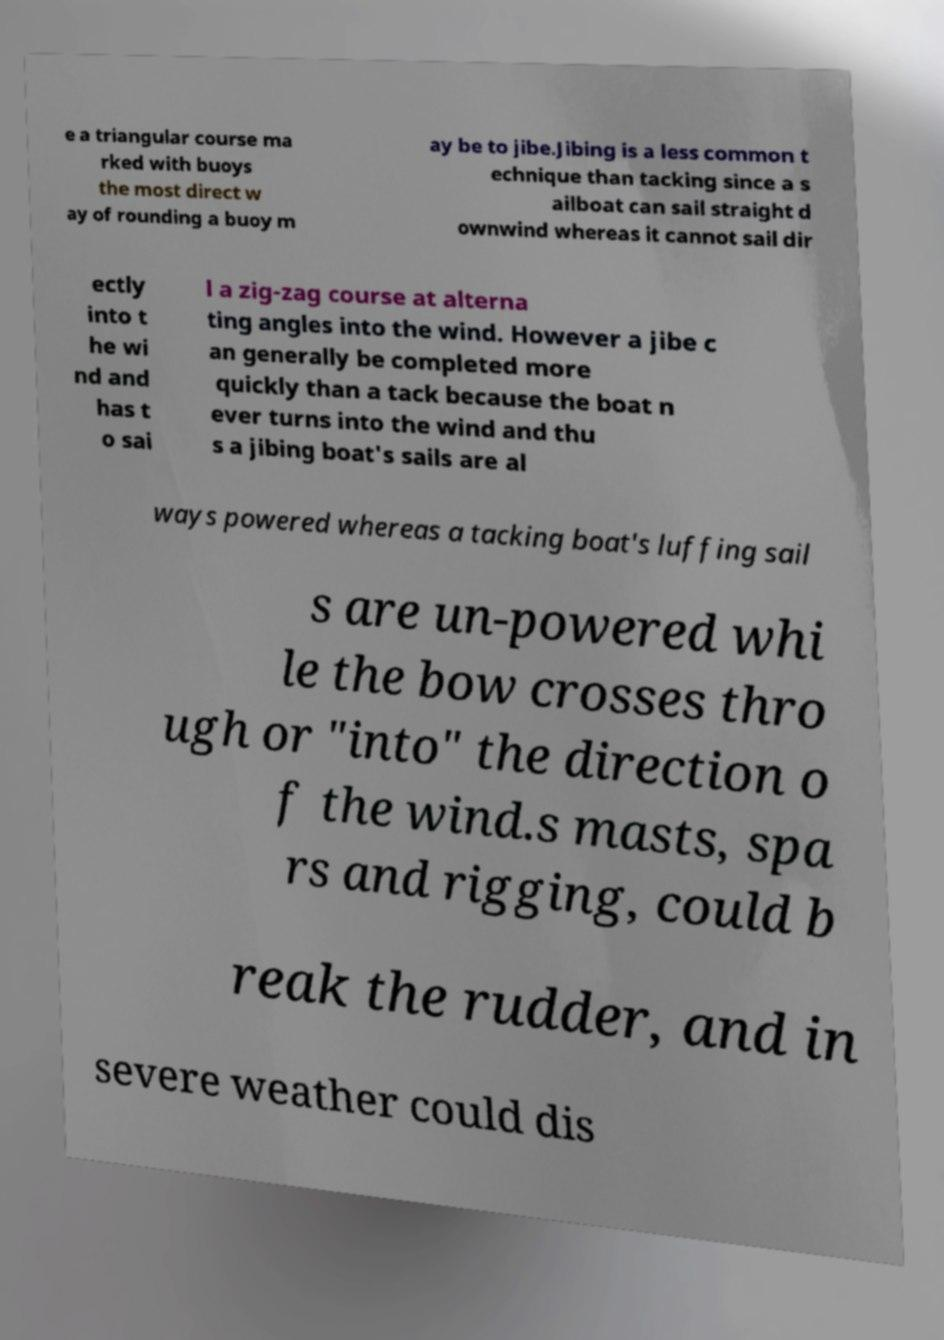Could you extract and type out the text from this image? e a triangular course ma rked with buoys the most direct w ay of rounding a buoy m ay be to jibe.Jibing is a less common t echnique than tacking since a s ailboat can sail straight d ownwind whereas it cannot sail dir ectly into t he wi nd and has t o sai l a zig-zag course at alterna ting angles into the wind. However a jibe c an generally be completed more quickly than a tack because the boat n ever turns into the wind and thu s a jibing boat's sails are al ways powered whereas a tacking boat's luffing sail s are un-powered whi le the bow crosses thro ugh or "into" the direction o f the wind.s masts, spa rs and rigging, could b reak the rudder, and in severe weather could dis 